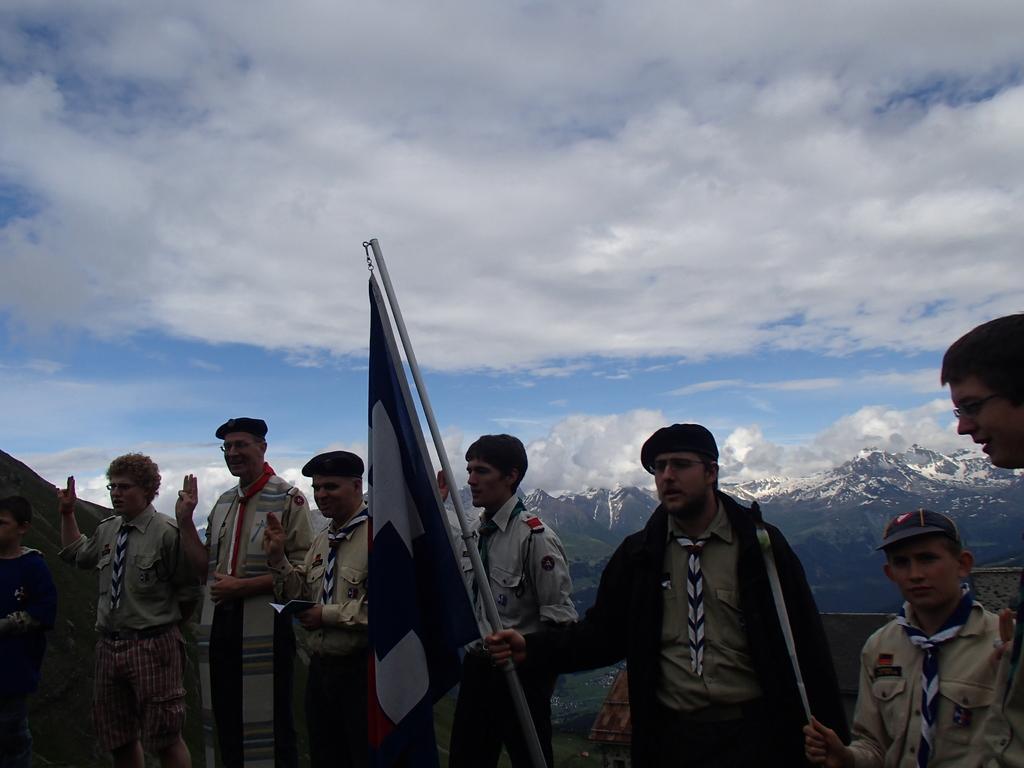In one or two sentences, can you explain what this image depicts? In this image I can see there are few men standing in a line, they are holding flags and in the background, I can see there are few mountains, they are covered with trees, snow and the sky is clear. 